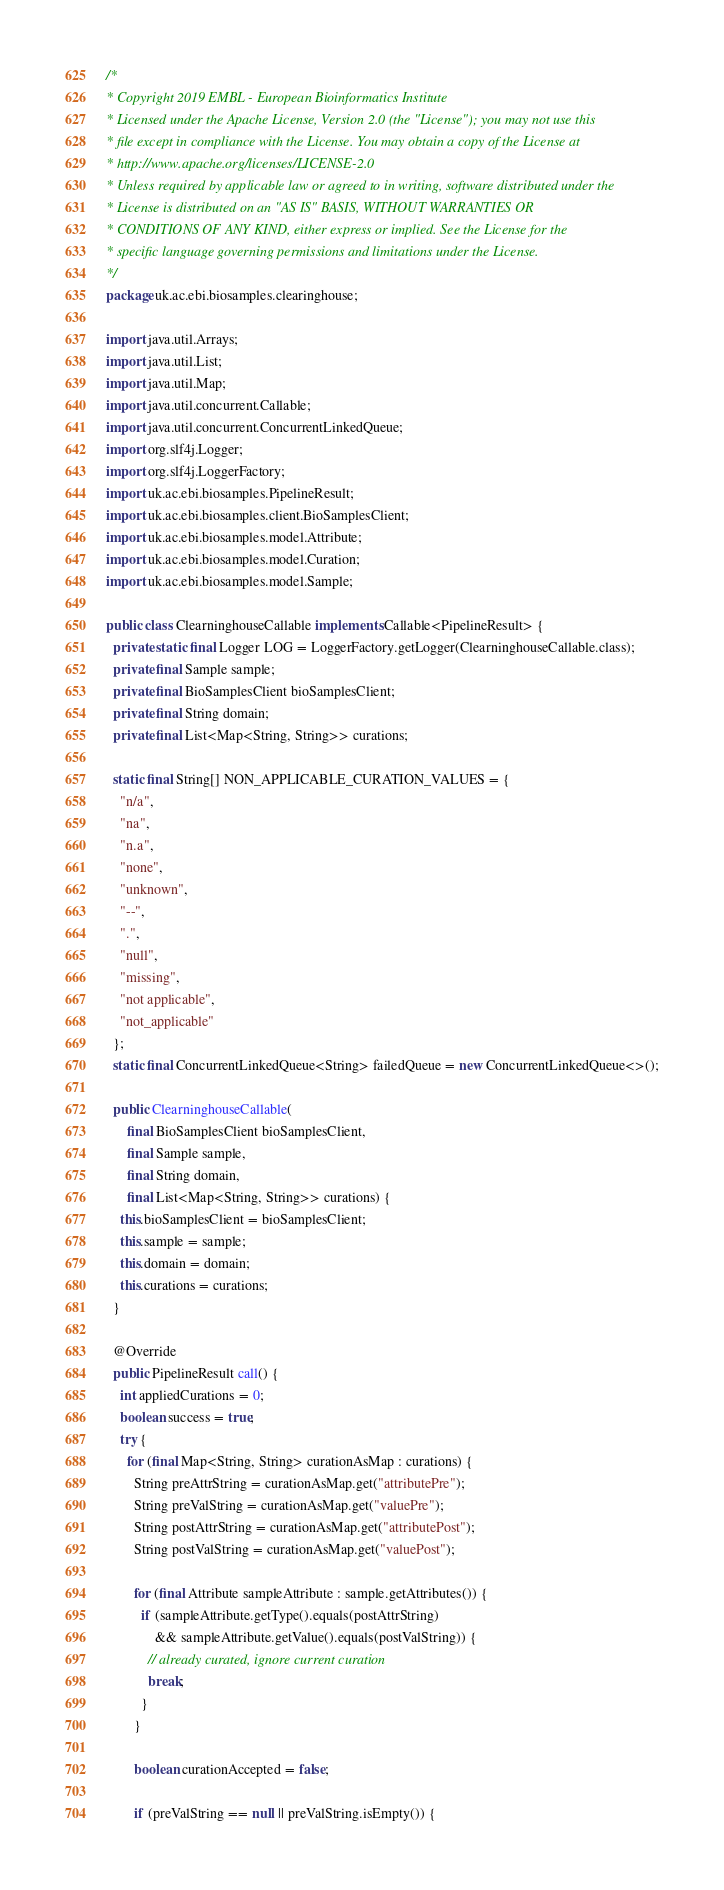Convert code to text. <code><loc_0><loc_0><loc_500><loc_500><_Java_>/*
* Copyright 2019 EMBL - European Bioinformatics Institute
* Licensed under the Apache License, Version 2.0 (the "License"); you may not use this
* file except in compliance with the License. You may obtain a copy of the License at
* http://www.apache.org/licenses/LICENSE-2.0
* Unless required by applicable law or agreed to in writing, software distributed under the
* License is distributed on an "AS IS" BASIS, WITHOUT WARRANTIES OR
* CONDITIONS OF ANY KIND, either express or implied. See the License for the
* specific language governing permissions and limitations under the License.
*/
package uk.ac.ebi.biosamples.clearinghouse;

import java.util.Arrays;
import java.util.List;
import java.util.Map;
import java.util.concurrent.Callable;
import java.util.concurrent.ConcurrentLinkedQueue;
import org.slf4j.Logger;
import org.slf4j.LoggerFactory;
import uk.ac.ebi.biosamples.PipelineResult;
import uk.ac.ebi.biosamples.client.BioSamplesClient;
import uk.ac.ebi.biosamples.model.Attribute;
import uk.ac.ebi.biosamples.model.Curation;
import uk.ac.ebi.biosamples.model.Sample;

public class ClearninghouseCallable implements Callable<PipelineResult> {
  private static final Logger LOG = LoggerFactory.getLogger(ClearninghouseCallable.class);
  private final Sample sample;
  private final BioSamplesClient bioSamplesClient;
  private final String domain;
  private final List<Map<String, String>> curations;

  static final String[] NON_APPLICABLE_CURATION_VALUES = {
    "n/a",
    "na",
    "n.a",
    "none",
    "unknown",
    "--",
    ".",
    "null",
    "missing",
    "not applicable",
    "not_applicable"
  };
  static final ConcurrentLinkedQueue<String> failedQueue = new ConcurrentLinkedQueue<>();

  public ClearninghouseCallable(
      final BioSamplesClient bioSamplesClient,
      final Sample sample,
      final String domain,
      final List<Map<String, String>> curations) {
    this.bioSamplesClient = bioSamplesClient;
    this.sample = sample;
    this.domain = domain;
    this.curations = curations;
  }

  @Override
  public PipelineResult call() {
    int appliedCurations = 0;
    boolean success = true;
    try {
      for (final Map<String, String> curationAsMap : curations) {
        String preAttrString = curationAsMap.get("attributePre");
        String preValString = curationAsMap.get("valuePre");
        String postAttrString = curationAsMap.get("attributePost");
        String postValString = curationAsMap.get("valuePost");

        for (final Attribute sampleAttribute : sample.getAttributes()) {
          if (sampleAttribute.getType().equals(postAttrString)
              && sampleAttribute.getValue().equals(postValString)) {
            // already curated, ignore current curation
            break;
          }
        }

        boolean curationAccepted = false;

        if (preValString == null || preValString.isEmpty()) {</code> 